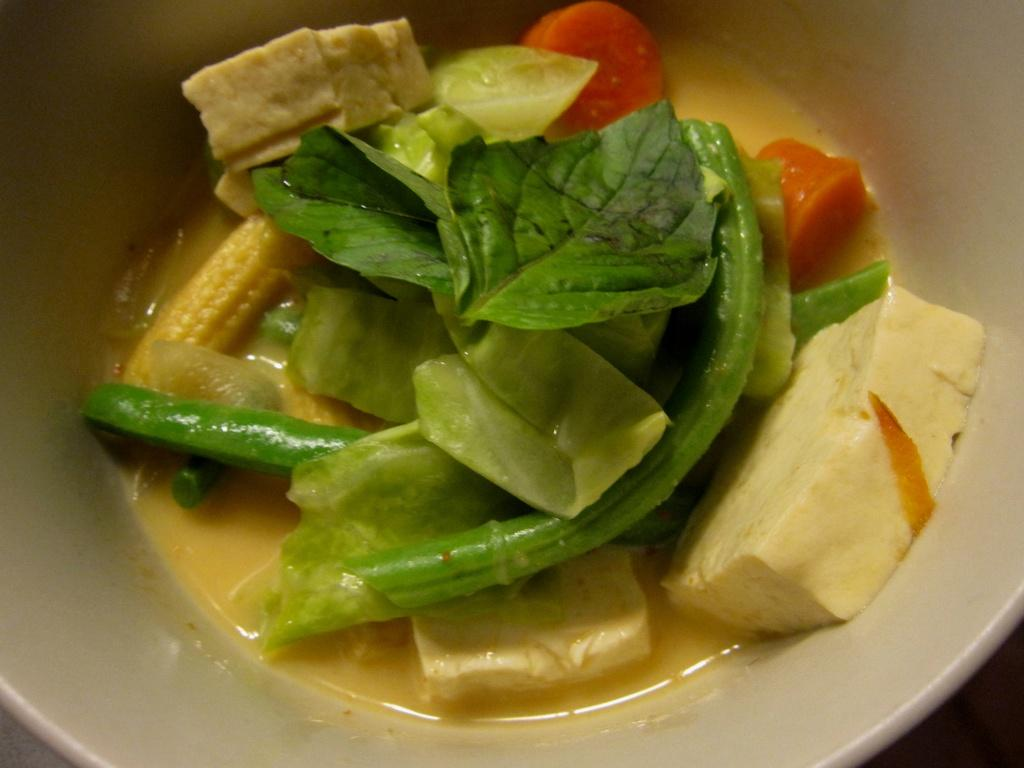What type of food can be seen in the image? There is food in the image, but the specific type is not mentioned. What else is present in the bowl with the food? There are leaves in the image, and they are placed in the bowl with the food. What type of wrench is being used to squeeze the juice from the leaves in the image? There is no wrench or juice present in the image; it only features food and leaves in a bowl. 